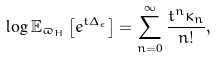Convert formula to latex. <formula><loc_0><loc_0><loc_500><loc_500>\log \mathbb { E } _ { \varpi _ { H } } \left [ e ^ { t \Delta _ { \epsilon } } \right ] = \sum _ { n = 0 } ^ { \infty } \frac { t ^ { n } \kappa _ { n } } { n ! } ,</formula> 